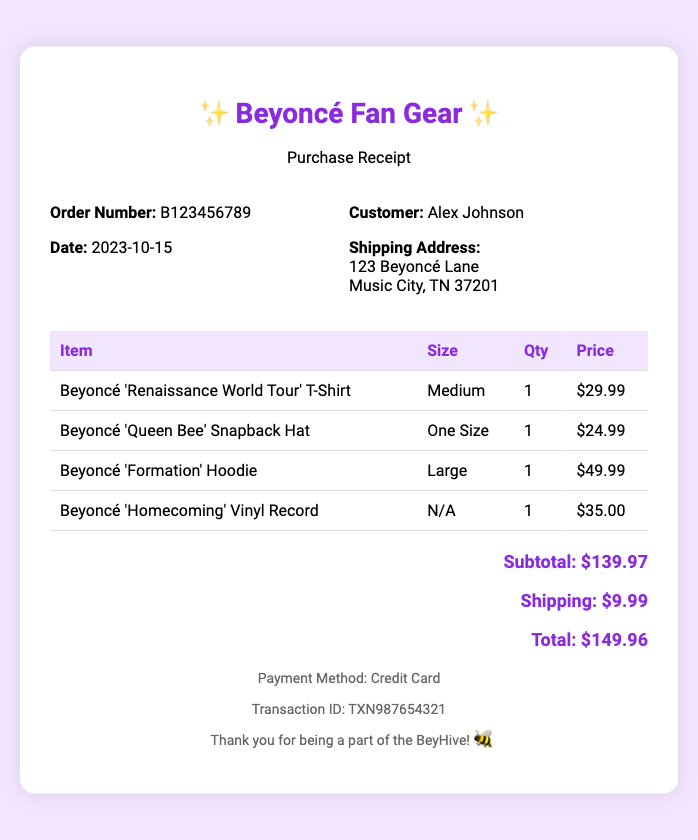What is the order number? The order number is clearly stated in the document for reference.
Answer: B123456789 What is the shipping cost? The shipping cost is listed in the total section of the document.
Answer: $9.99 What is the date of the purchase? The date is indicated in the order information section of the receipt.
Answer: 2023-10-15 How many items were purchased in total? The total number of items is the sum of all quantities listed in the document.
Answer: 4 What size is the 'Formation' Hoodie? The size information for each item is provided in the table.
Answer: Large What is the price of the 'Renaissance World Tour' T-Shirt? The pricing for each item can be found listed with the item description.
Answer: $29.99 Who is the customer? The customer's name is identified in the order information section.
Answer: Alex Johnson What is the total amount due? The total amount is calculated and provided at the end of the document.
Answer: $149.96 What type of payment method was used? The payment method is mentioned in the footer of the receipt.
Answer: Credit Card 